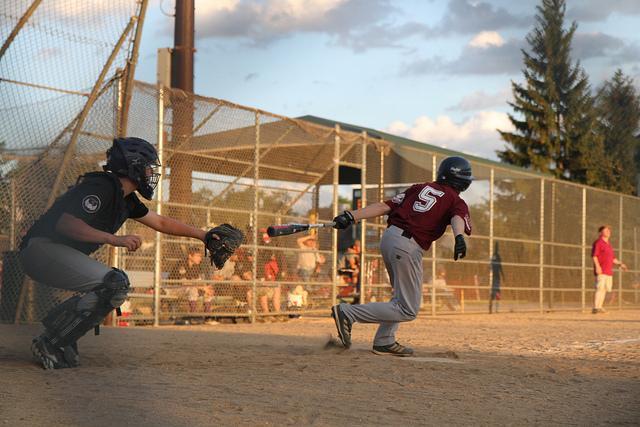How many people are visible?
Give a very brief answer. 3. How many trains do you see?
Give a very brief answer. 0. 